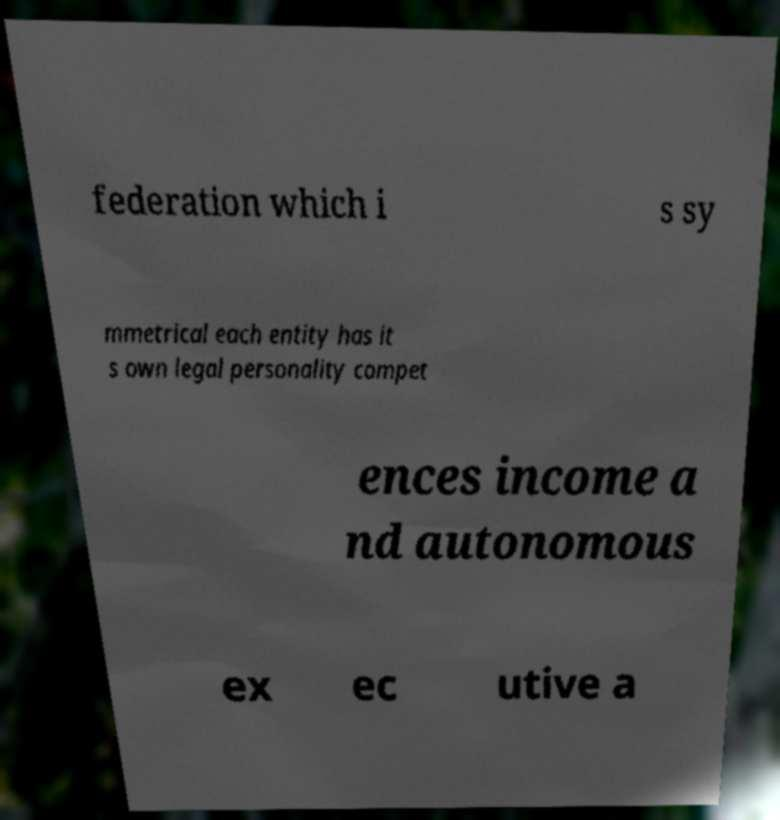For documentation purposes, I need the text within this image transcribed. Could you provide that? federation which i s sy mmetrical each entity has it s own legal personality compet ences income a nd autonomous ex ec utive a 